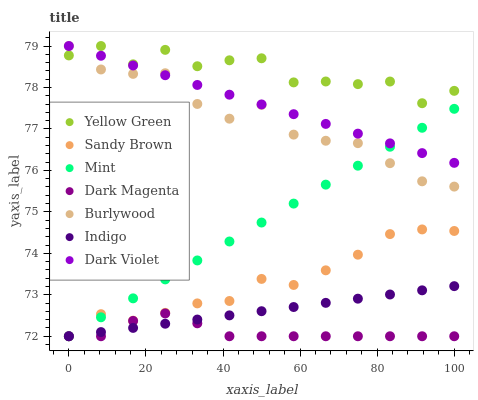Does Dark Magenta have the minimum area under the curve?
Answer yes or no. Yes. Does Yellow Green have the maximum area under the curve?
Answer yes or no. Yes. Does Burlywood have the minimum area under the curve?
Answer yes or no. No. Does Burlywood have the maximum area under the curve?
Answer yes or no. No. Is Dark Violet the smoothest?
Answer yes or no. Yes. Is Yellow Green the roughest?
Answer yes or no. Yes. Is Burlywood the smoothest?
Answer yes or no. No. Is Burlywood the roughest?
Answer yes or no. No. Does Indigo have the lowest value?
Answer yes or no. Yes. Does Burlywood have the lowest value?
Answer yes or no. No. Does Dark Violet have the highest value?
Answer yes or no. Yes. Does Sandy Brown have the highest value?
Answer yes or no. No. Is Mint less than Yellow Green?
Answer yes or no. Yes. Is Dark Violet greater than Sandy Brown?
Answer yes or no. Yes. Does Indigo intersect Mint?
Answer yes or no. Yes. Is Indigo less than Mint?
Answer yes or no. No. Is Indigo greater than Mint?
Answer yes or no. No. Does Mint intersect Yellow Green?
Answer yes or no. No. 